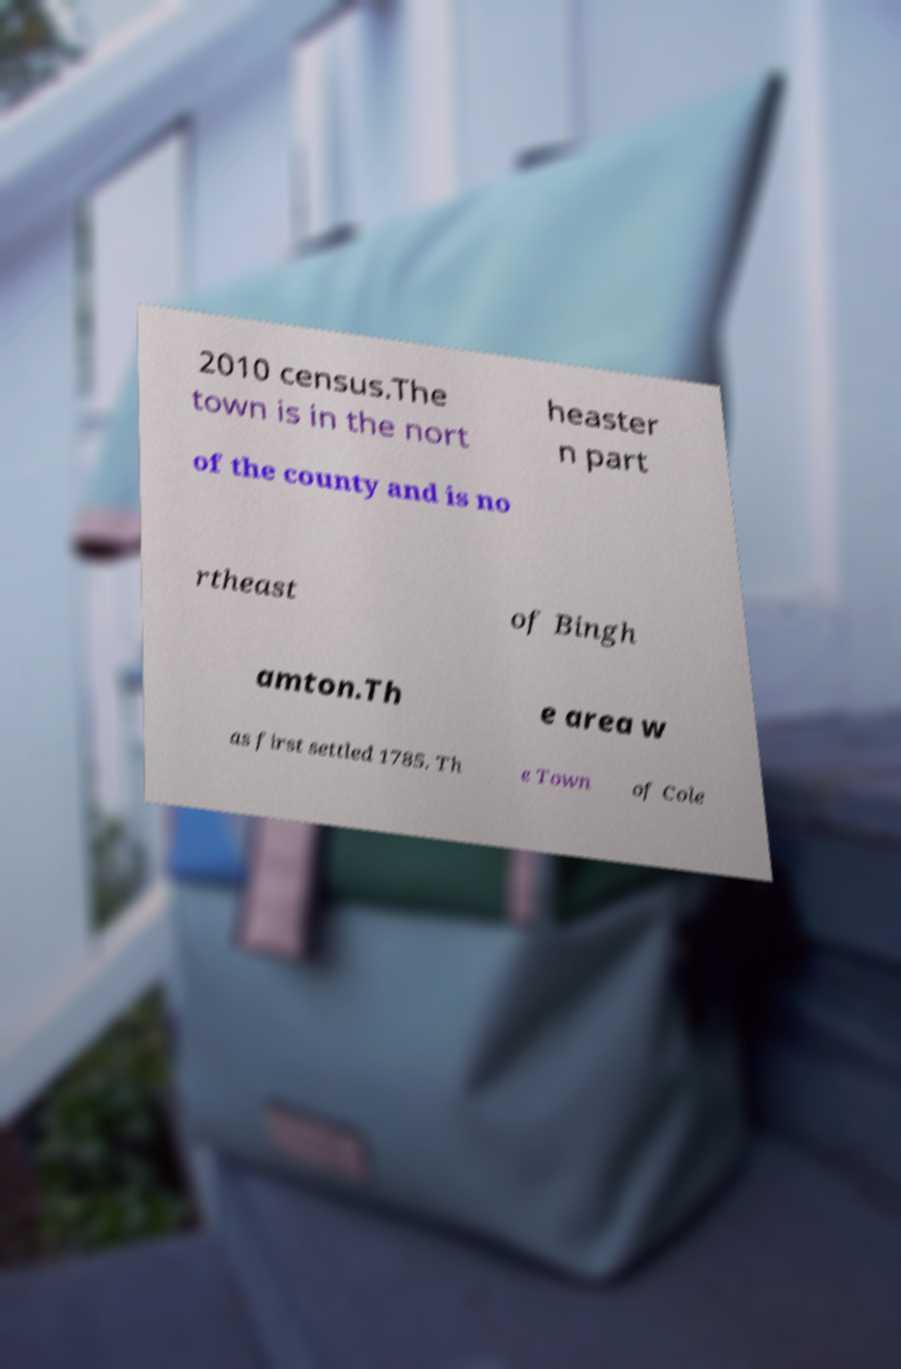Could you extract and type out the text from this image? 2010 census.The town is in the nort heaster n part of the county and is no rtheast of Bingh amton.Th e area w as first settled 1785. Th e Town of Cole 